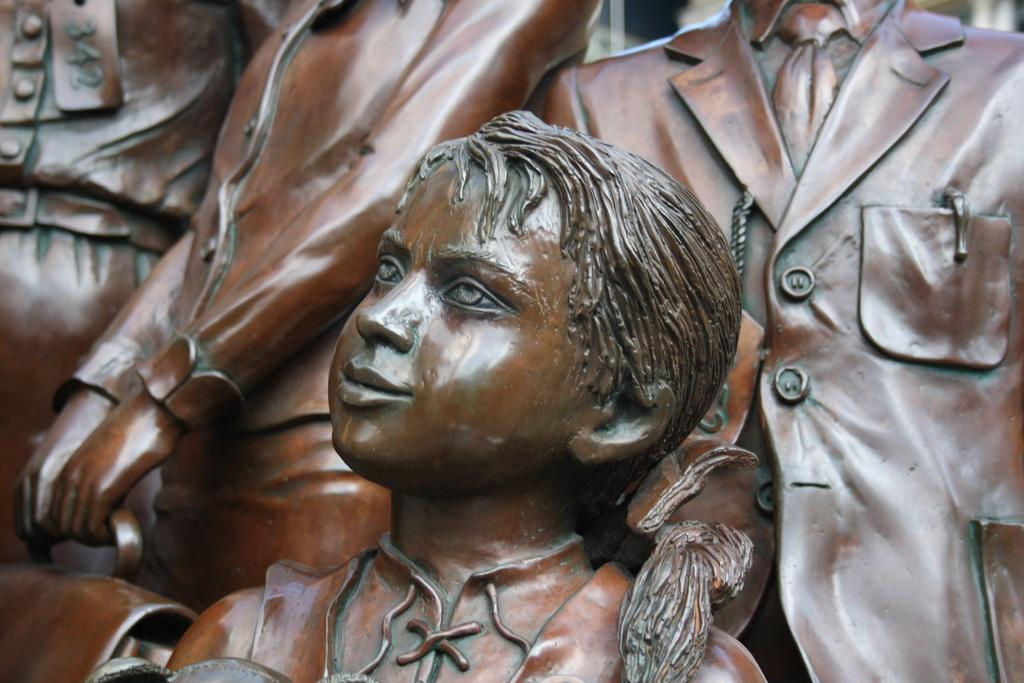What type of sculpture is present in the image? There is a small girl wooden sculpture in the image. How many sculptures are present in total? There are four sculptures in the image, including the small girl wooden sculpture. Can you describe the other sculptures? There are three more sculptures of men in the image. What hobbies do the ministers depicted in the sculptures have? There are no ministers depicted in the sculptures, and therefore no information about their hobbies can be determined from the image. 